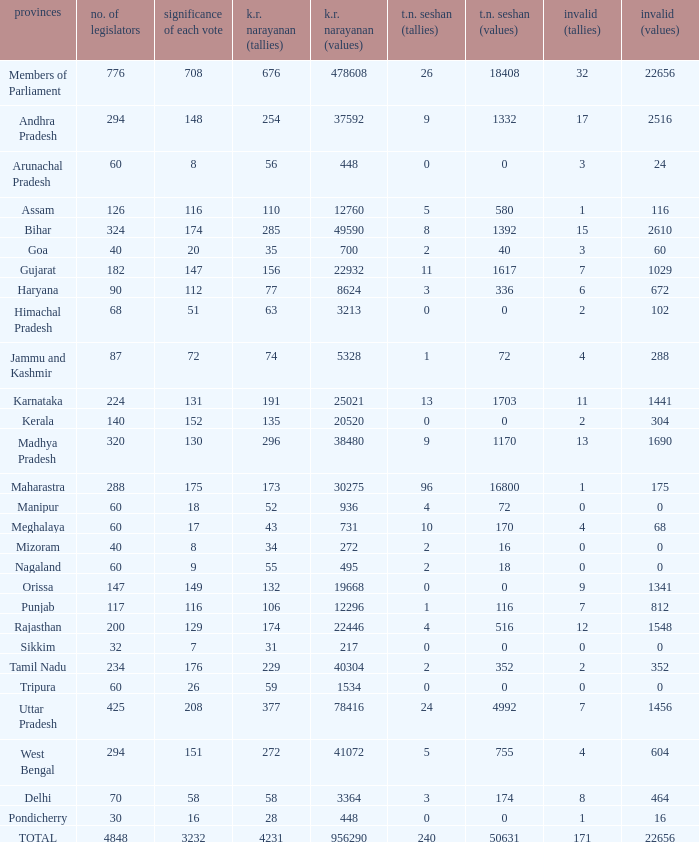Name the number of tn seshan values for kr values is 478608 1.0. 